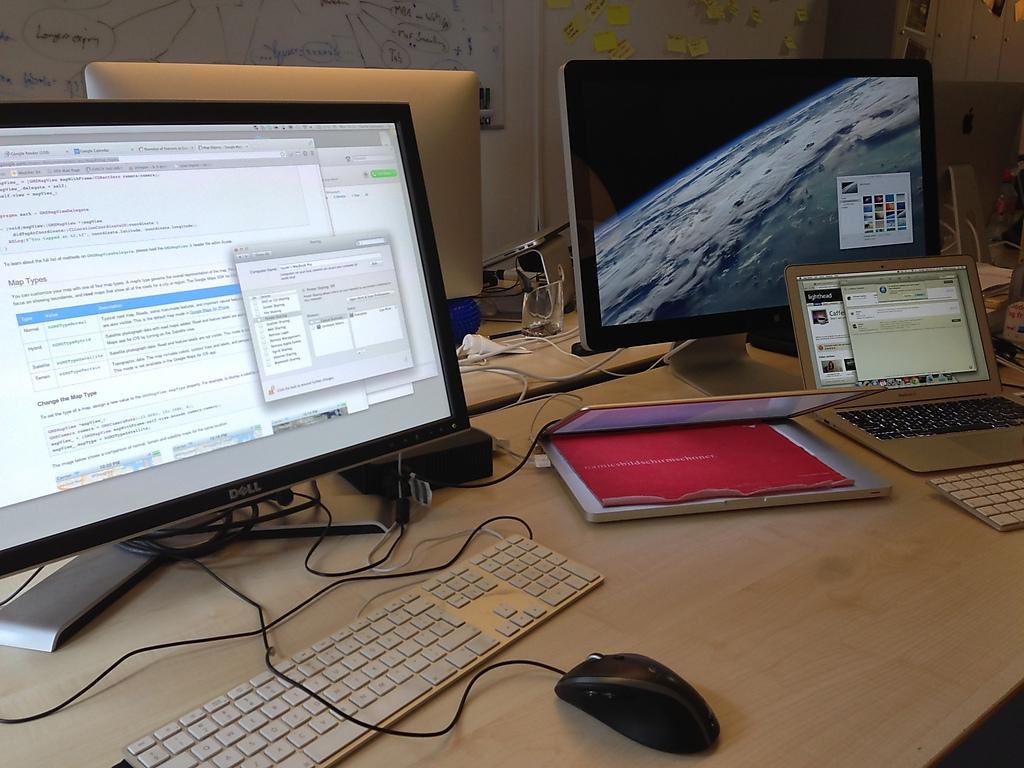<image>
Share a concise interpretation of the image provided. A Dell brand monitor has a few different windows open on it. 